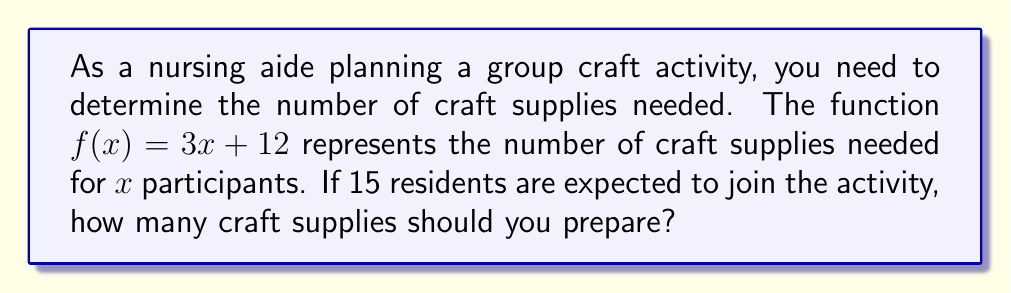Help me with this question. To solve this problem, we need to follow these steps:

1. Identify the given information:
   - The function is $f(x) = 3x + 12$
   - $x$ represents the number of participants
   - There are 15 residents expected to join

2. Substitute the number of participants (15) into the function:
   $f(15) = 3(15) + 12$

3. Calculate the result:
   $f(15) = 45 + 12 = 57$

Therefore, for 15 participants, you should prepare 57 craft supplies.
Answer: 57 craft supplies 